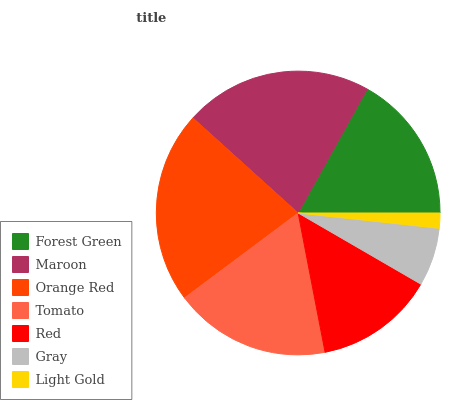Is Light Gold the minimum?
Answer yes or no. Yes. Is Orange Red the maximum?
Answer yes or no. Yes. Is Maroon the minimum?
Answer yes or no. No. Is Maroon the maximum?
Answer yes or no. No. Is Maroon greater than Forest Green?
Answer yes or no. Yes. Is Forest Green less than Maroon?
Answer yes or no. Yes. Is Forest Green greater than Maroon?
Answer yes or no. No. Is Maroon less than Forest Green?
Answer yes or no. No. Is Forest Green the high median?
Answer yes or no. Yes. Is Forest Green the low median?
Answer yes or no. Yes. Is Red the high median?
Answer yes or no. No. Is Tomato the low median?
Answer yes or no. No. 